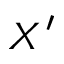<formula> <loc_0><loc_0><loc_500><loc_500>X ^ { \prime }</formula> 